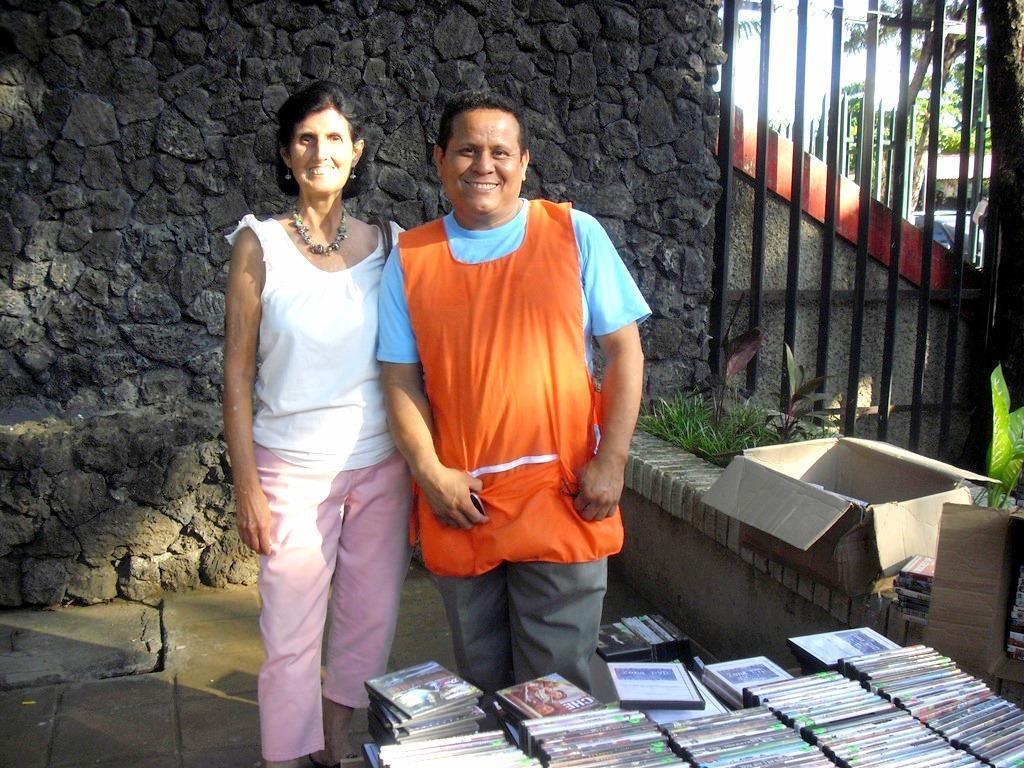How would you summarize this image in a sentence or two? In this picture we can see a man and a woman standing on the path. We can see a few books. There are some boxes on the wall. We can see a few trees are visible in the background. 